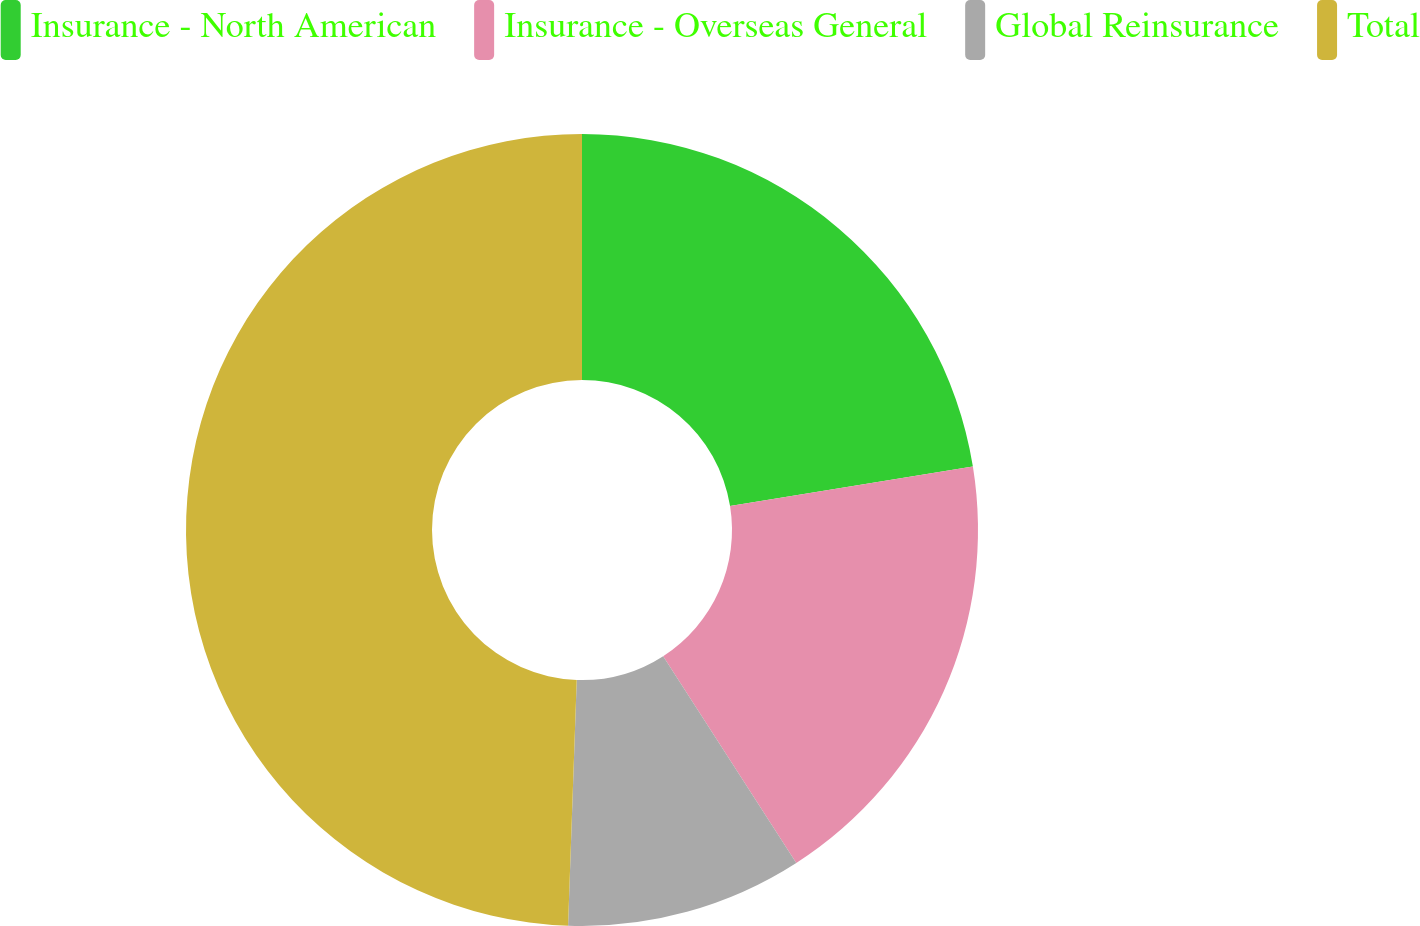Convert chart. <chart><loc_0><loc_0><loc_500><loc_500><pie_chart><fcel>Insurance - North American<fcel>Insurance - Overseas General<fcel>Global Reinsurance<fcel>Total<nl><fcel>22.44%<fcel>18.46%<fcel>9.66%<fcel>49.44%<nl></chart> 